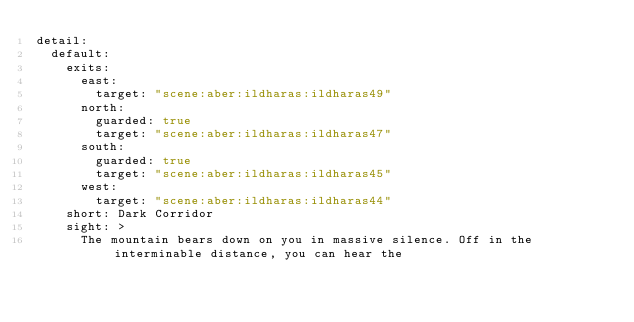Convert code to text. <code><loc_0><loc_0><loc_500><loc_500><_YAML_>detail:
  default:
    exits:
      east:
        target: "scene:aber:ildharas:ildharas49"
      north:
        guarded: true
        target: "scene:aber:ildharas:ildharas47"
      south:
        guarded: true
        target: "scene:aber:ildharas:ildharas45"
      west:
        target: "scene:aber:ildharas:ildharas44"
    short: Dark Corridor
    sight: >
      The mountain bears down on you in massive silence. Off in the interminable distance, you can hear the</code> 